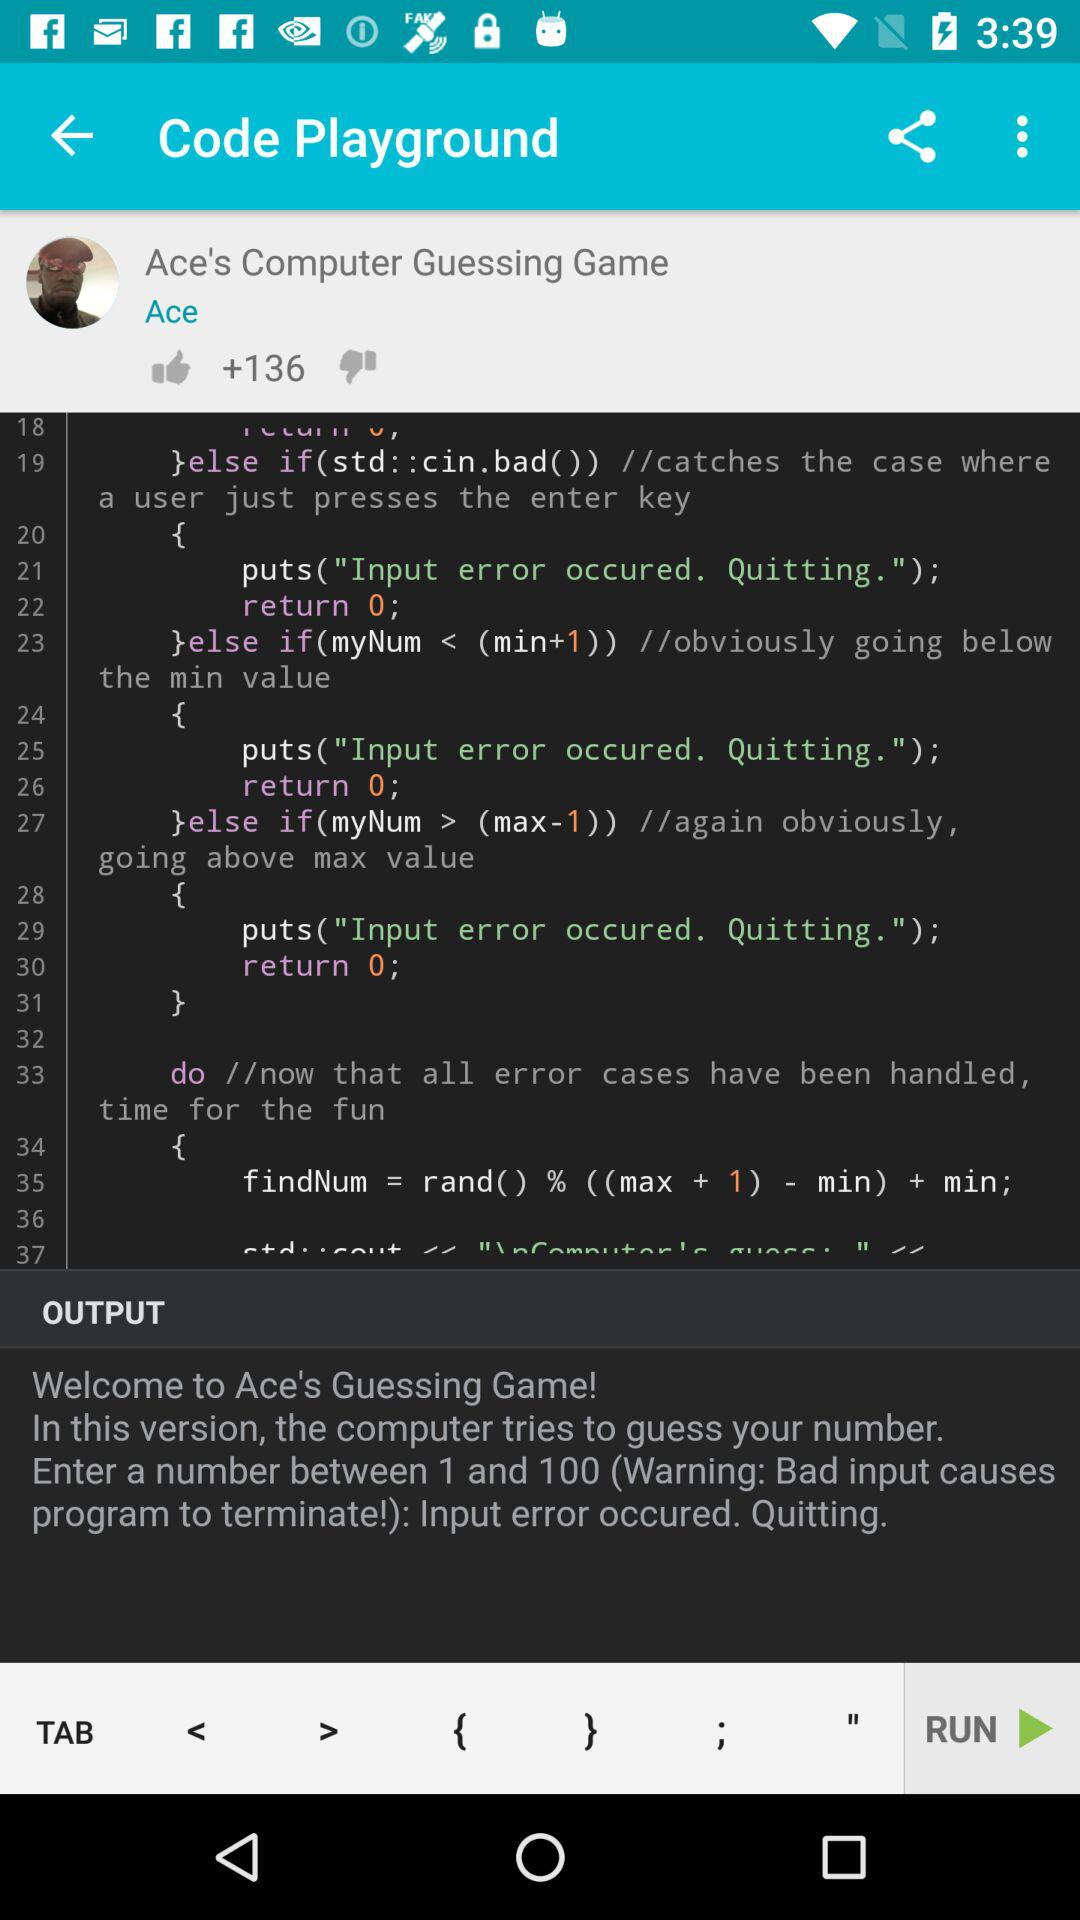What is the name of the game? The name of the game is Ace's Computer Guessing Game. 